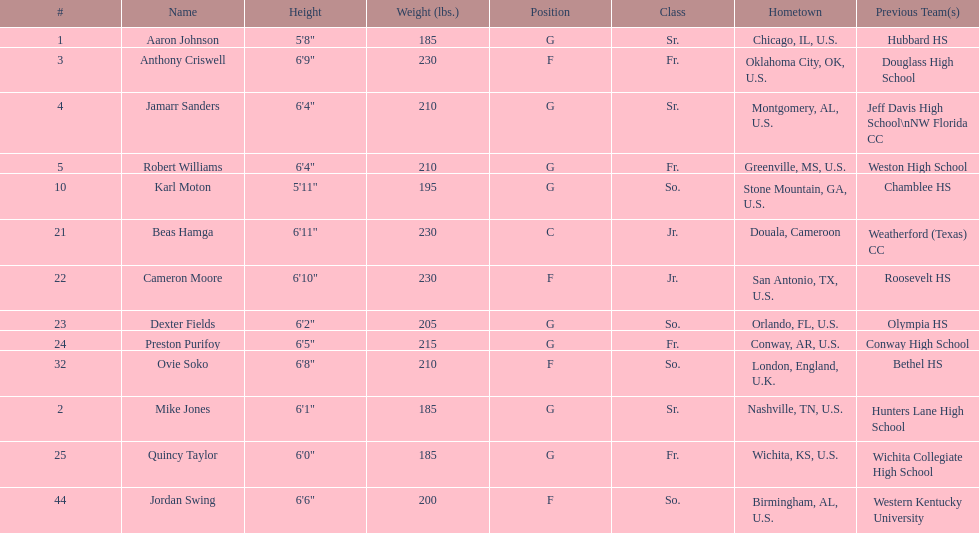What's the count of players hailing from alabama? 2. 